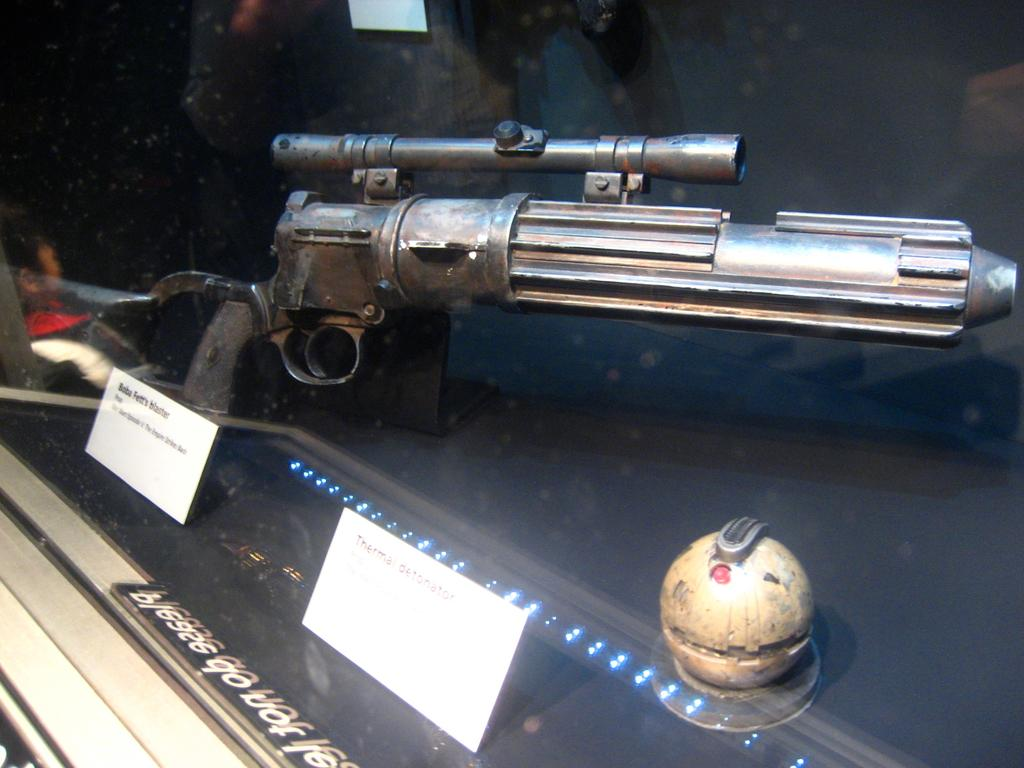What is placed in the glass box in the image? There is a gun placed in a glass box in the image. What can be seen in the image besides the gun in the glass box? There are small tags and an object visible in the image. Can you describe the person on the left side of the image? There is a person on the left side of the image, but no specific details about their appearance or clothing are provided. What type of sky can be seen in the image? There is no sky visible in the image; it is focused on the gun in the glass box and other objects in the foreground. What color is the patch on the person's skirt in the image? There is no person wearing a skirt in the image, and therefore no patch to describe. 